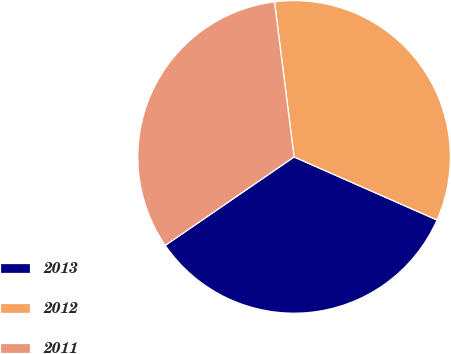<chart> <loc_0><loc_0><loc_500><loc_500><pie_chart><fcel>2013<fcel>2012<fcel>2011<nl><fcel>33.81%<fcel>33.61%<fcel>32.58%<nl></chart> 